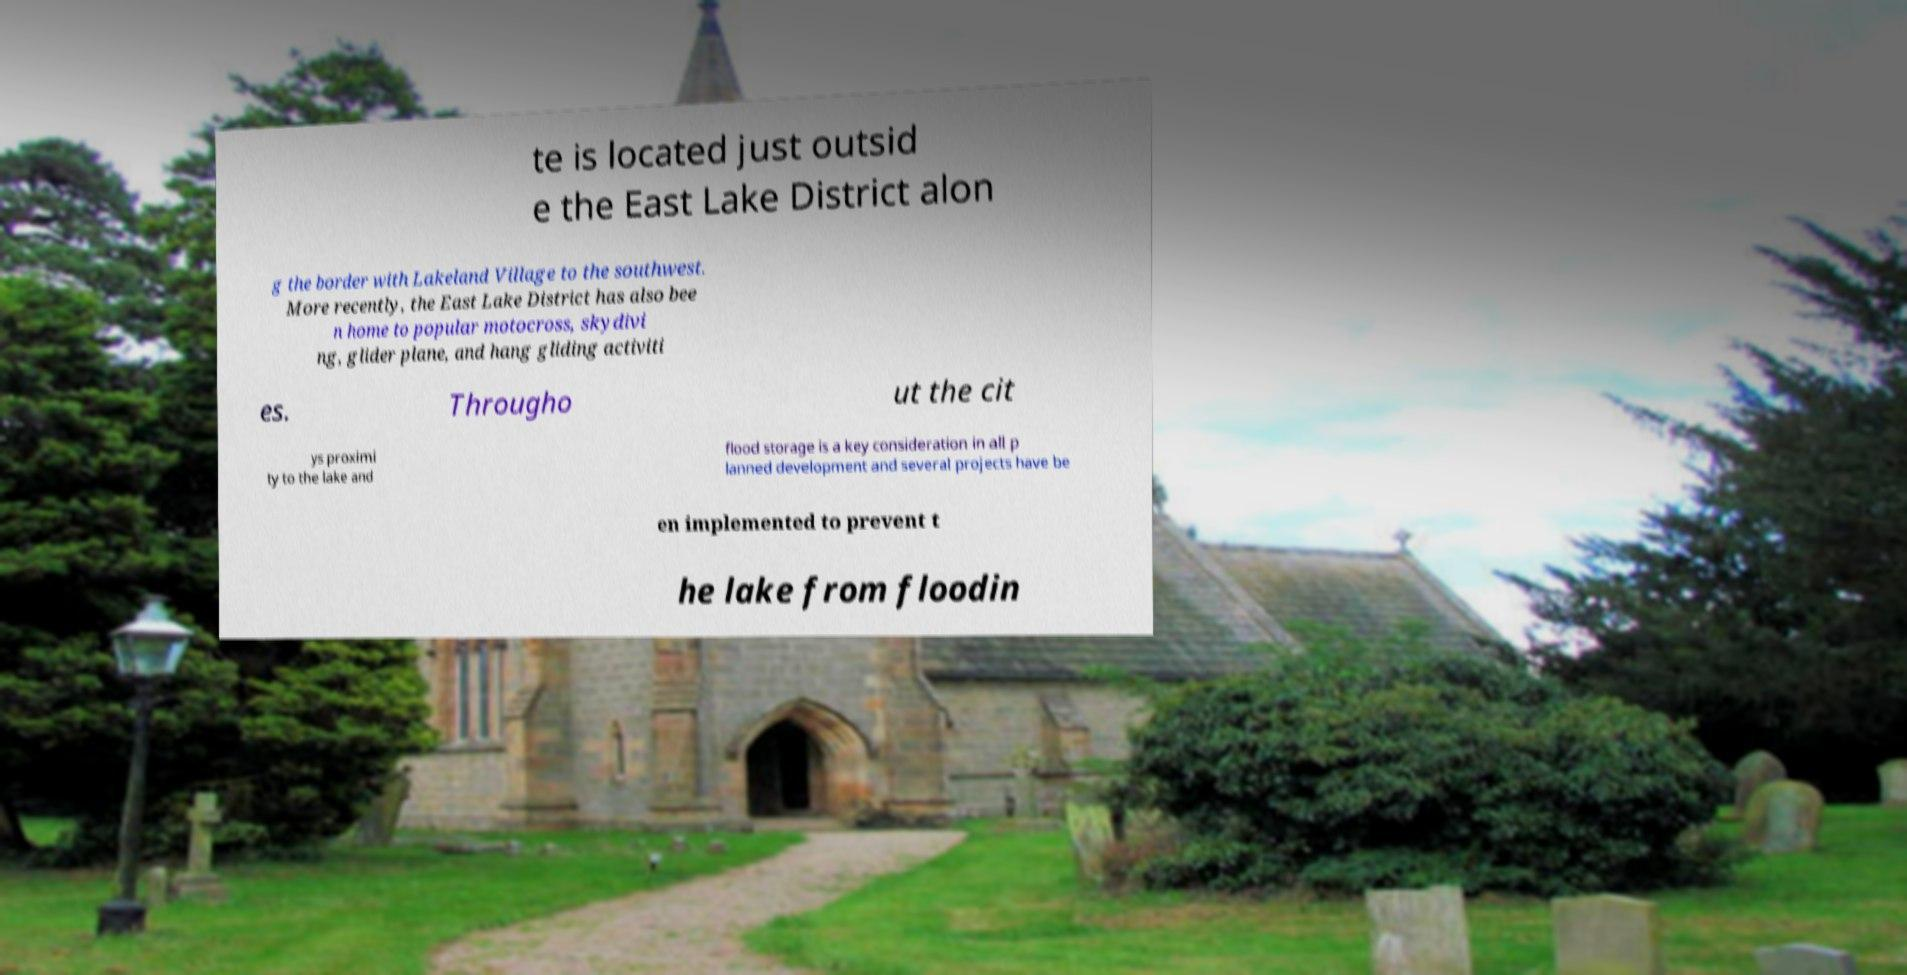Could you extract and type out the text from this image? te is located just outsid e the East Lake District alon g the border with Lakeland Village to the southwest. More recently, the East Lake District has also bee n home to popular motocross, skydivi ng, glider plane, and hang gliding activiti es. Througho ut the cit ys proximi ty to the lake and flood storage is a key consideration in all p lanned development and several projects have be en implemented to prevent t he lake from floodin 